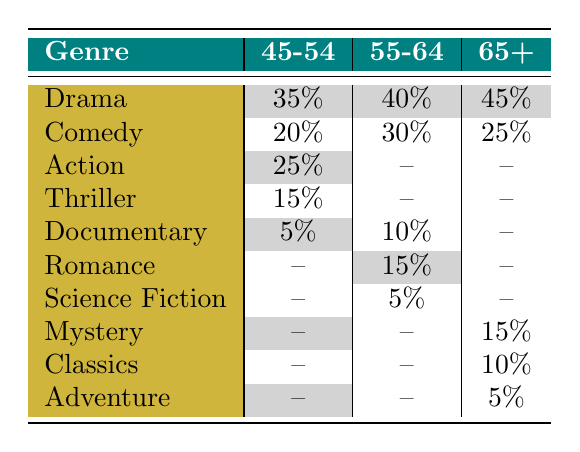What is the most preferred film genre for the age group 65+? The age group 65+ has the highest percentage preference for Drama at 45%. This can be found by looking at the row for the genre Drama under the column for the age group 65+.
Answer: Drama Which genre has the lowest percentage of preference among the age group 45-54? In the age group 45-54, the genre with the lowest preference is Documentary, with a percentage of 5%. This is shown in the row for Documentary under the column for the age group 45-54.
Answer: 5% How does the preference for Comedy compare between the age groups 55-64 and 45-54? For the age group 55-64, the preference for Comedy is 30%, while for the age group 45-54 it is 20%. This shows that the 55-64 age group prefers Comedy more than the 45-54 age group by a difference of 10%.
Answer: The 55-64 age group prefers Comedy more What is the combined percentage of preference for Action and Thriller in the age group 45-54? In the age group 45-54, Action has a preference of 25%, and Thriller has a preference of 15%. When we add these percentages together (25 + 15), we get a combined percentage of 40%.
Answer: 40% Is it true that Mystery is preferred equally by the age groups 55-64 and 65+? Looking at the table, Mystery is not listed under the age group 55-64 but is listed with a percentage of 15% for the age group 65+. Therefore, it is not true that Mystery is preferred equally between these two age groups.
Answer: No Which age group has the highest percentage for Drama and what is that percentage? The age group 65+ has the highest percentage for Drama, with a preference of 45%. This can be confirmed by checking the Drama row across all age groups.
Answer: 45% What is the percentage of preference for Documentaries among the age group 55-64, and how does it compare to the overall trend of increased interest among older demographics? The percentage of preference for Documentaries in the age group 55-64 is 10%. The trend indicates that older audiences are showing increased interest in documentaries, which aligns with a gradual rise in this genre's preference among demographics, suggesting a growing appreciation.
Answer: 10% How many genres have a preference of 15% or more in the age group 65+? In the age group 65+, the genres with a preference of 15% or more are Drama (45%), Comedy (25%), and Mystery (15%). This makes a total of three genres.
Answer: 3 